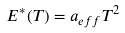Convert formula to latex. <formula><loc_0><loc_0><loc_500><loc_500>E ^ { * } ( T ) = a _ { e f f } T ^ { 2 }</formula> 